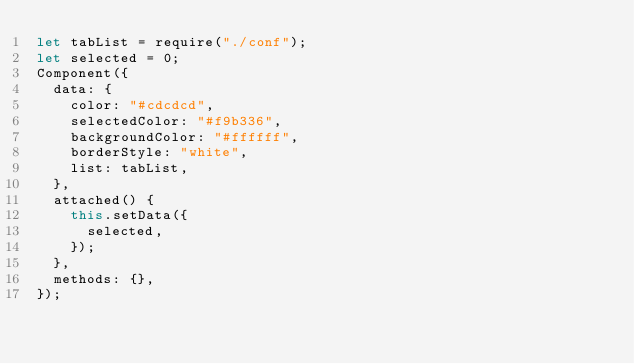Convert code to text. <code><loc_0><loc_0><loc_500><loc_500><_JavaScript_>let tabList = require("./conf");
let selected = 0;
Component({
  data: {
    color: "#cdcdcd",
    selectedColor: "#f9b336",
    backgroundColor: "#ffffff",
    borderStyle: "white",
    list: tabList,
  },
  attached() {
    this.setData({
      selected,
    });
  },
  methods: {},
});
</code> 